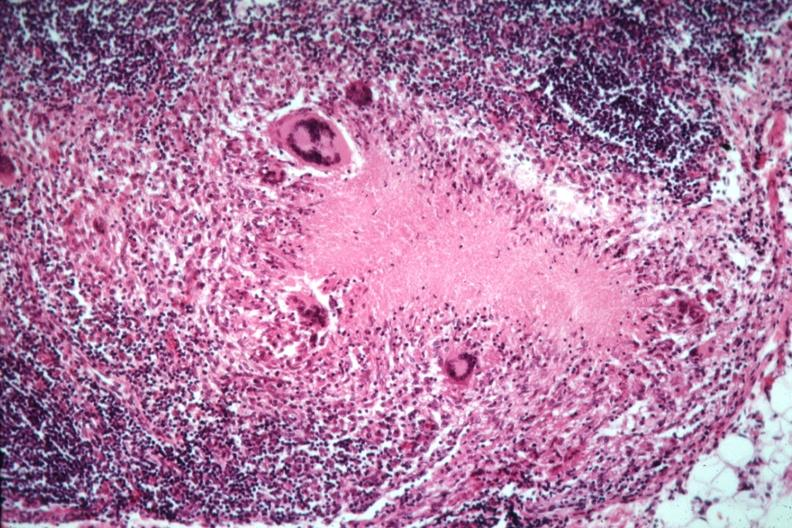s antitrypsin present?
Answer the question using a single word or phrase. No 